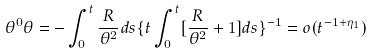<formula> <loc_0><loc_0><loc_500><loc_500>\theta ^ { 0 } \theta = - \int _ { 0 } ^ { t } \frac { R } { \theta ^ { 2 } } d s \{ t \int _ { 0 } ^ { t } [ \frac { R } { \theta ^ { 2 } } + 1 ] d s \} ^ { - 1 } = o ( t ^ { - 1 + \eta _ { 1 } } )</formula> 